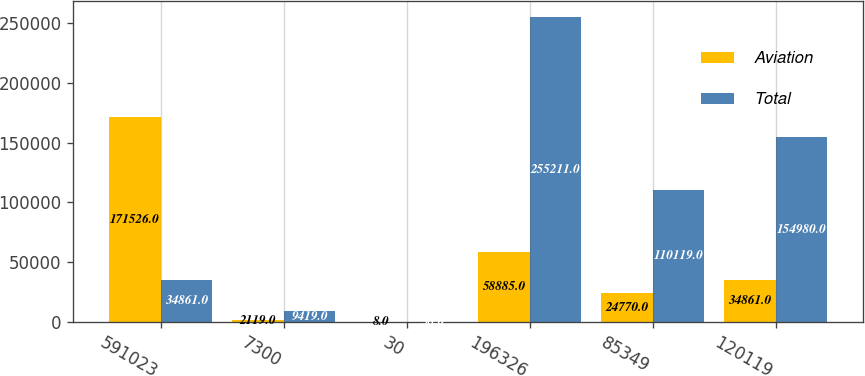Convert chart. <chart><loc_0><loc_0><loc_500><loc_500><stacked_bar_chart><ecel><fcel>591023<fcel>7300<fcel>30<fcel>196326<fcel>85349<fcel>120119<nl><fcel>Aviation<fcel>171526<fcel>2119<fcel>8<fcel>58885<fcel>24770<fcel>34861<nl><fcel>Total<fcel>34861<fcel>9419<fcel>38<fcel>255211<fcel>110119<fcel>154980<nl></chart> 